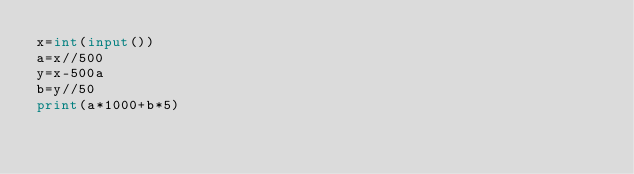<code> <loc_0><loc_0><loc_500><loc_500><_Python_>x=int(input())
a=x//500
y=x-500a
b=y//50
print(a*1000+b*5)</code> 